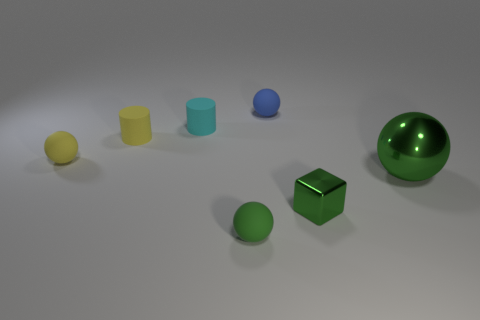How many other things are there of the same material as the cyan thing?
Give a very brief answer. 4. Is the tiny blue thing made of the same material as the tiny cyan cylinder?
Make the answer very short. Yes. There is a matte sphere to the left of the cyan rubber thing; what number of blue spheres are in front of it?
Offer a very short reply. 0. Are there any small yellow things that have the same shape as the blue rubber thing?
Offer a terse response. Yes. There is a small green thing to the right of the blue matte ball; is its shape the same as the thing behind the small cyan cylinder?
Give a very brief answer. No. There is a thing that is both behind the tiny yellow rubber sphere and in front of the small cyan matte object; what shape is it?
Make the answer very short. Cylinder. Are there any blue rubber objects that have the same size as the yellow cylinder?
Your answer should be compact. Yes. Do the cube and the sphere in front of the green metal block have the same color?
Ensure brevity in your answer.  Yes. What material is the yellow sphere?
Offer a very short reply. Rubber. There is a metallic object behind the metallic block; what color is it?
Provide a short and direct response. Green. 